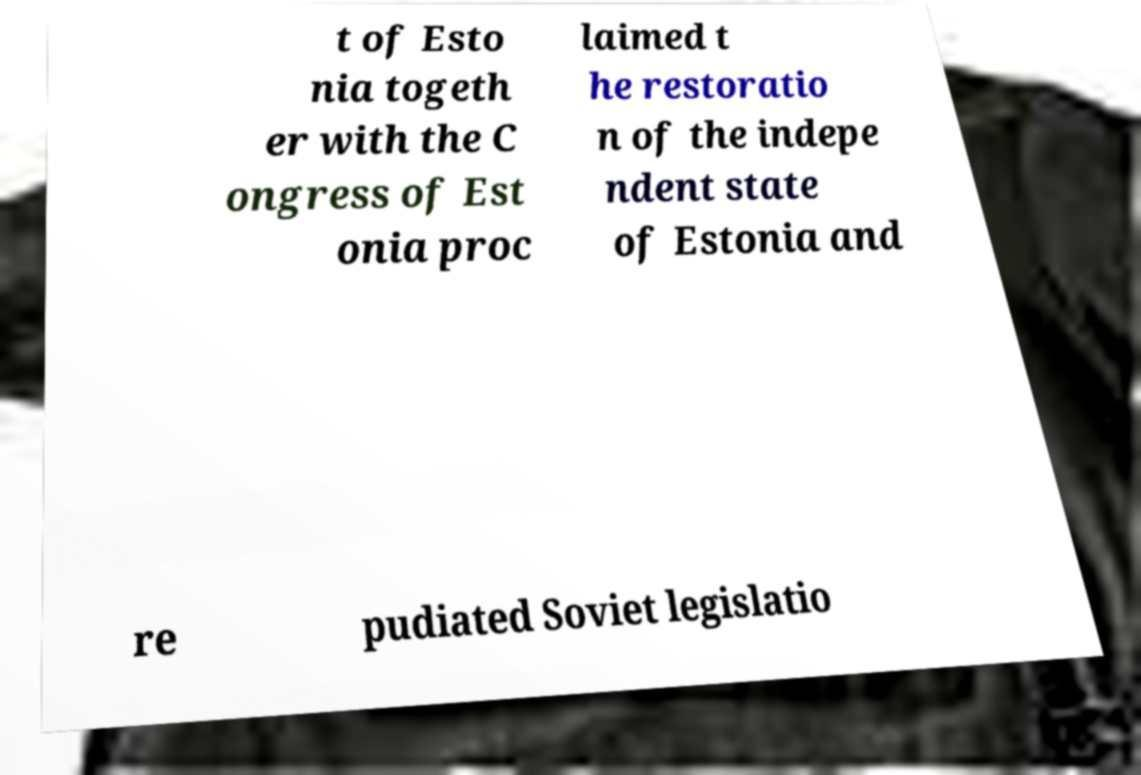Can you read and provide the text displayed in the image?This photo seems to have some interesting text. Can you extract and type it out for me? t of Esto nia togeth er with the C ongress of Est onia proc laimed t he restoratio n of the indepe ndent state of Estonia and re pudiated Soviet legislatio 